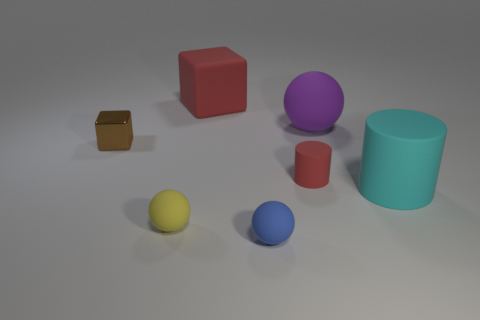How many cylinders are there?
Your answer should be compact. 2. What shape is the big thing that is to the right of the rubber ball that is right of the small red cylinder that is in front of the metallic cube?
Give a very brief answer. Cylinder. Are there fewer small yellow rubber balls to the left of the red rubber block than matte objects in front of the tiny cube?
Provide a short and direct response. Yes. Do the large object that is on the left side of the blue rubber sphere and the tiny thing left of the yellow rubber thing have the same shape?
Your answer should be compact. Yes. There is a matte object that is to the right of the ball behind the brown metal object; what shape is it?
Make the answer very short. Cylinder. There is a matte object that is the same color as the rubber block; what is its size?
Your response must be concise. Small. Are there any blue things made of the same material as the yellow ball?
Your response must be concise. Yes. There is a big object that is in front of the tiny brown metallic cube; what material is it?
Keep it short and to the point. Rubber. What is the material of the small cube?
Your answer should be very brief. Metal. Are the tiny thing right of the blue object and the large red thing made of the same material?
Your answer should be compact. Yes. 